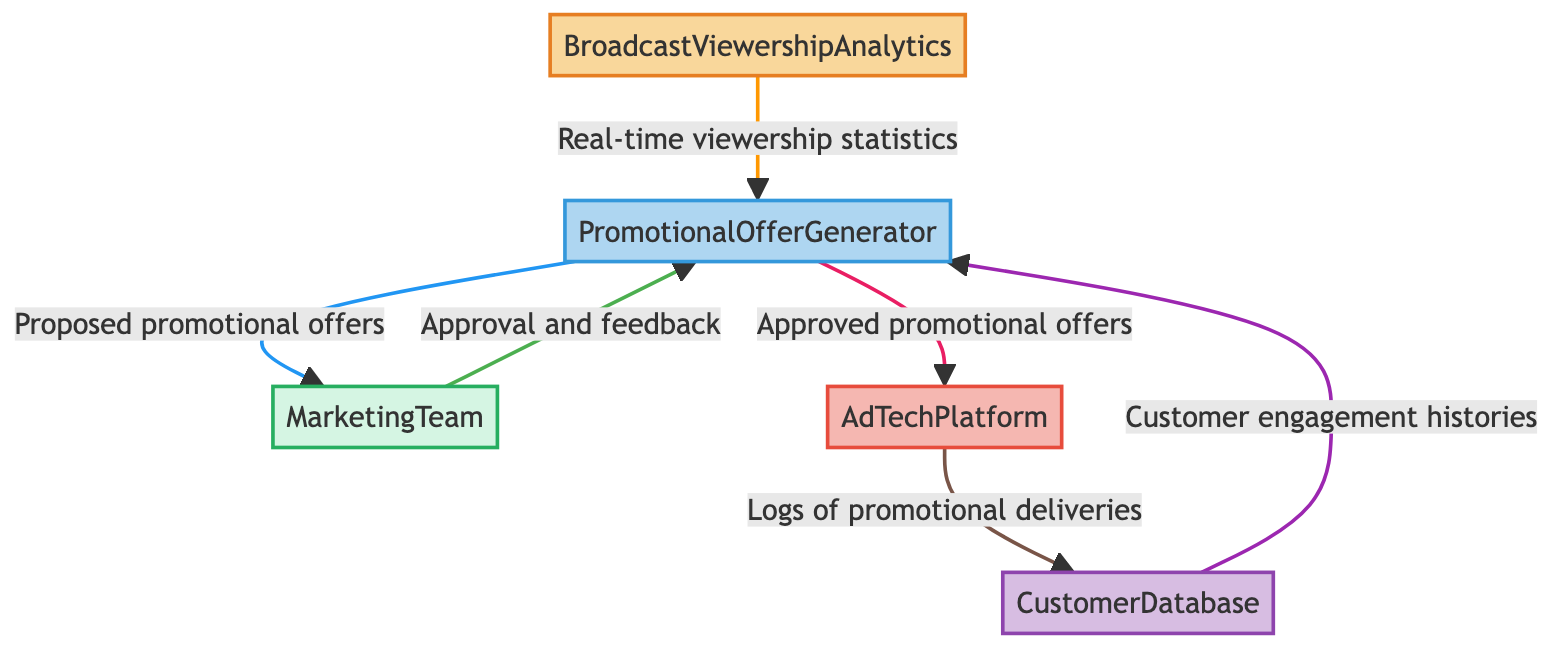What is the primary data source in the diagram? The primary data source is labeled as "BroadcastViewershipAnalytics," which gathers real-time viewership data from various broadcast channels.
Answer: BroadcastViewershipAnalytics How many data flows are shown in the diagram? By counting the arrows indicating data flows from one component to another, there are a total of six data flows illustrated in the diagram.
Answer: 6 What does the PromotionalOfferGenerator produce? The PromotionalOfferGenerator produces "Proposed promotional offers based on viewership analytics," which are then sent to the MarketingTeam.
Answer: Proposed promotional offers Which external entity receives insights from the PromotionalOfferGenerator? The external entity that receives insights is the "MarketingTeam," which reviews and approves promotional strategies based on the generated offers.
Answer: MarketingTeam What type of data is sent from AdTechPlatform to CustomerDatabase? The data that flows from AdTechPlatform to CustomerDatabase consists of "Logs of promotional offer deliveries and customer interactions." This reflects the system's tracking of the promotional processes.
Answer: Logs of promotional deliveries What feedback does the MarketingTeam provide to the PromotionalOfferGenerator? The MarketingTeam provides "Approval and feedback on promotional strategies" to the PromotionalOfferGenerator to iterate on the proposed offers based on data analysis.
Answer: Approval and feedback How does the CustomerDatabase contribute to the PromotionalOfferGenerator? The CustomerDatabase contributes "Customer engagement histories and target demographics," providing vital data that helps the PromotionalOfferGenerator tailor its promotions.
Answer: Customer engagement histories Which entities are connected through a system in the diagram? The entities connected through a system are "PromotionalOfferGenerator" and "AdTechPlatform," with the promotional offers being delivered to broadcast channels as part of the advertising process.
Answer: PromotionalOfferGenerator and AdTechPlatform What is the role of the AdTechPlatform in the diagram? The role of the AdTechPlatform is to "Deliver the promotional content to broadcast channels" as it processes approved promotional offers from the PromotionalOfferGenerator.
Answer: Deliver the promotional content to broadcast channels 